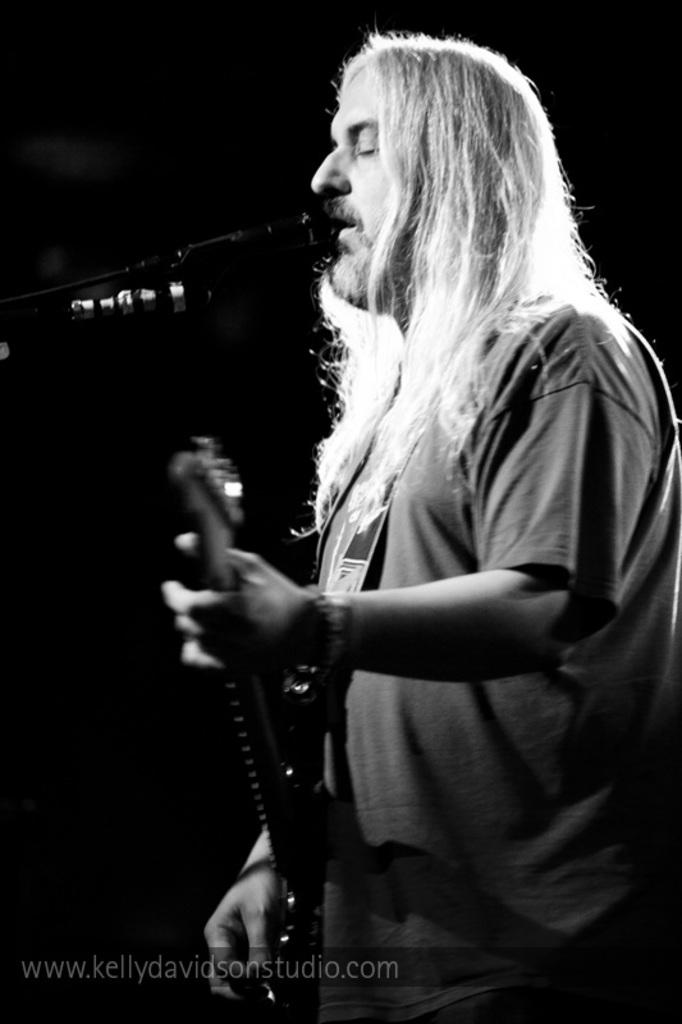What is the man in the image doing? The man is playing a guitar, singing, and using a microphone. What is the man wearing while performing? The man is wearing a t-shirt. Can you describe the man's appearance? The man has long hair. What type of honey is the man using to sweeten his voice in the image? There is no honey present in the image, and the man is not using any substance to sweeten his voice. 